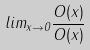Convert formula to latex. <formula><loc_0><loc_0><loc_500><loc_500>l i m _ { x \rightarrow 0 } \frac { O ( x ) } { O ( x ) }</formula> 